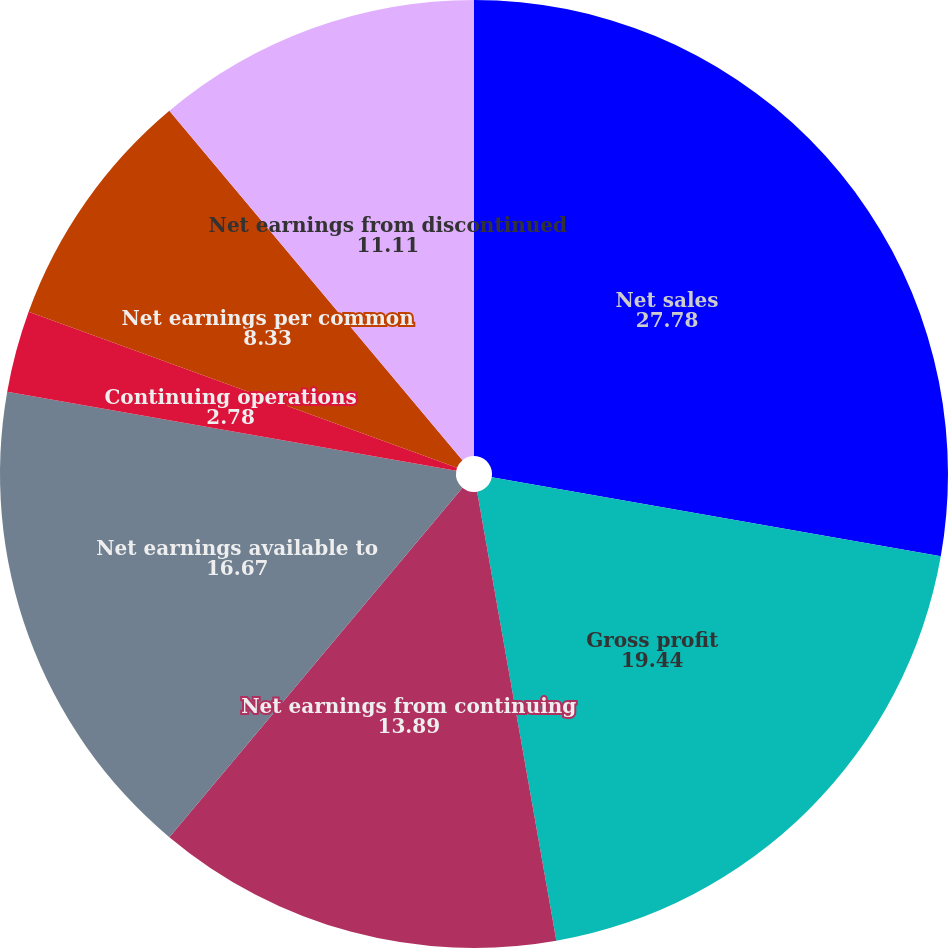Convert chart. <chart><loc_0><loc_0><loc_500><loc_500><pie_chart><fcel>Net sales<fcel>Gross profit<fcel>Net earnings from continuing<fcel>Net earnings available to<fcel>Continuing operations<fcel>Net earnings per common<fcel>Net earnings from discontinued<fcel>Discontinued operations<nl><fcel>27.78%<fcel>19.44%<fcel>13.89%<fcel>16.67%<fcel>2.78%<fcel>8.33%<fcel>11.11%<fcel>0.0%<nl></chart> 